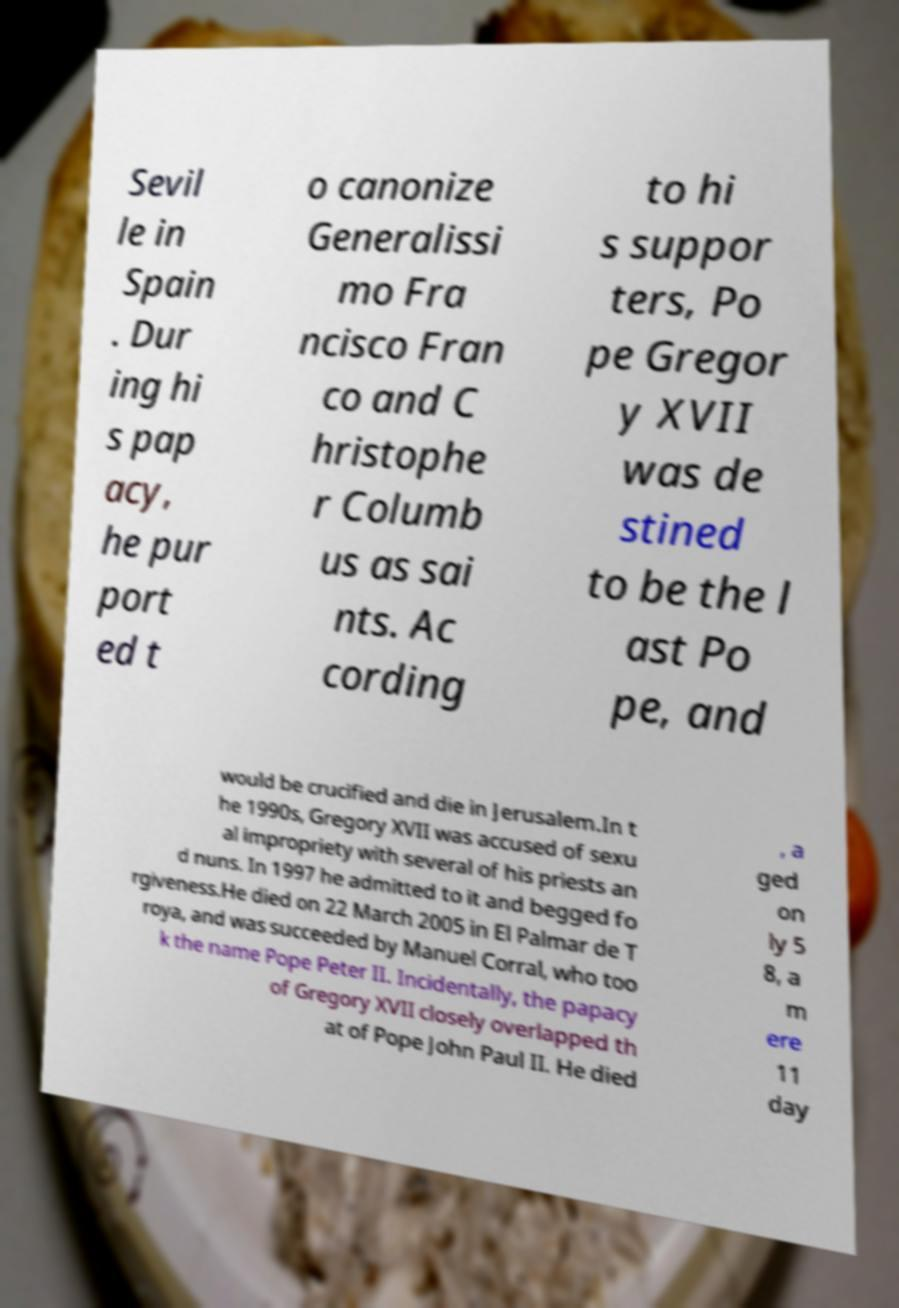Please identify and transcribe the text found in this image. Sevil le in Spain . Dur ing hi s pap acy, he pur port ed t o canonize Generalissi mo Fra ncisco Fran co and C hristophe r Columb us as sai nts. Ac cording to hi s suppor ters, Po pe Gregor y XVII was de stined to be the l ast Po pe, and would be crucified and die in Jerusalem.In t he 1990s, Gregory XVII was accused of sexu al impropriety with several of his priests an d nuns. In 1997 he admitted to it and begged fo rgiveness.He died on 22 March 2005 in El Palmar de T roya, and was succeeded by Manuel Corral, who too k the name Pope Peter II. Incidentally, the papacy of Gregory XVII closely overlapped th at of Pope John Paul II. He died , a ged on ly 5 8, a m ere 11 day 